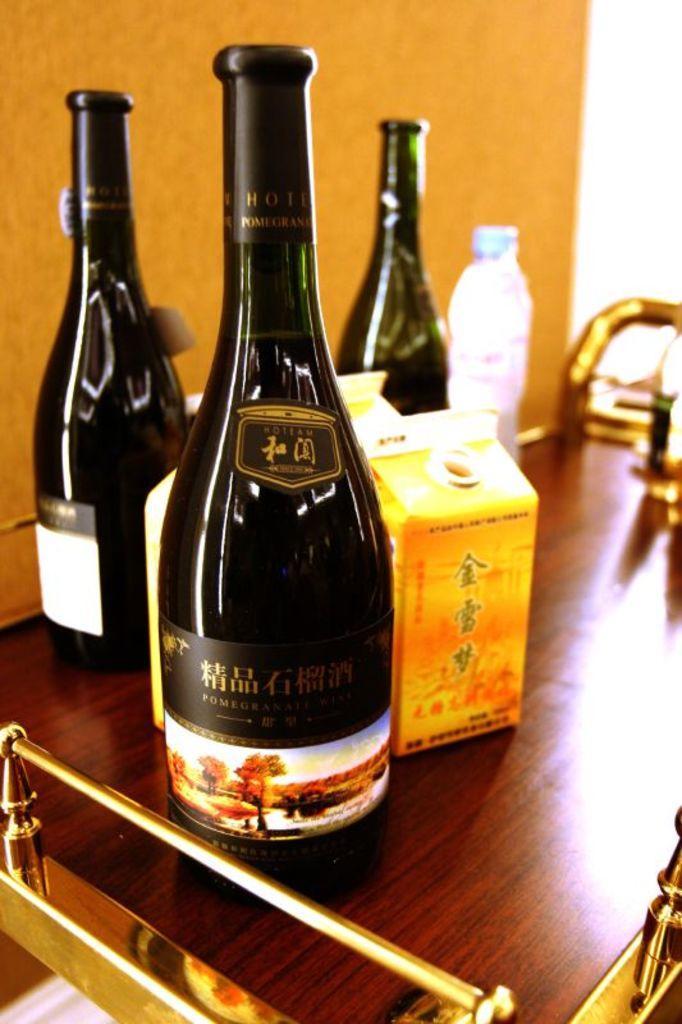Describe this image in one or two sentences. There are three wine bottles placed on the table along with box and small water bottle here. In the background there is a wall. 